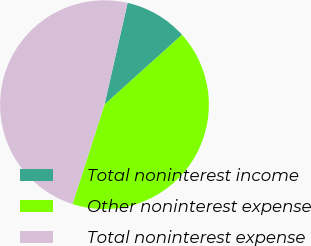Convert chart to OTSL. <chart><loc_0><loc_0><loc_500><loc_500><pie_chart><fcel>Total noninterest income<fcel>Other noninterest expense<fcel>Total noninterest expense<nl><fcel>9.77%<fcel>41.62%<fcel>48.61%<nl></chart> 